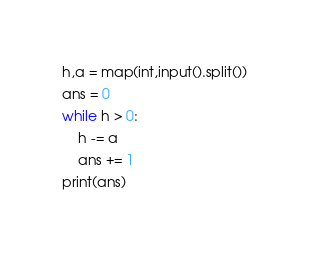Convert code to text. <code><loc_0><loc_0><loc_500><loc_500><_Python_>h,a = map(int,input().split())
ans = 0
while h > 0:
    h -= a
    ans += 1
print(ans)</code> 